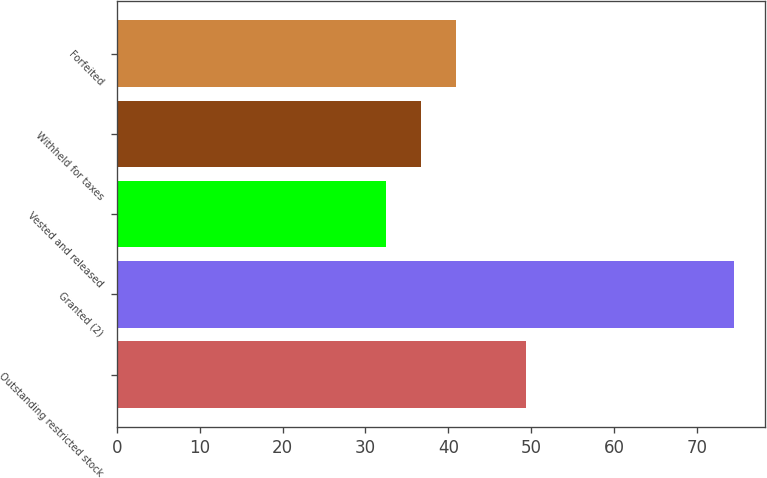Convert chart. <chart><loc_0><loc_0><loc_500><loc_500><bar_chart><fcel>Outstanding restricted stock<fcel>Granted (2)<fcel>Vested and released<fcel>Withheld for taxes<fcel>Forfeited<nl><fcel>49.36<fcel>74.48<fcel>32.5<fcel>36.7<fcel>40.9<nl></chart> 